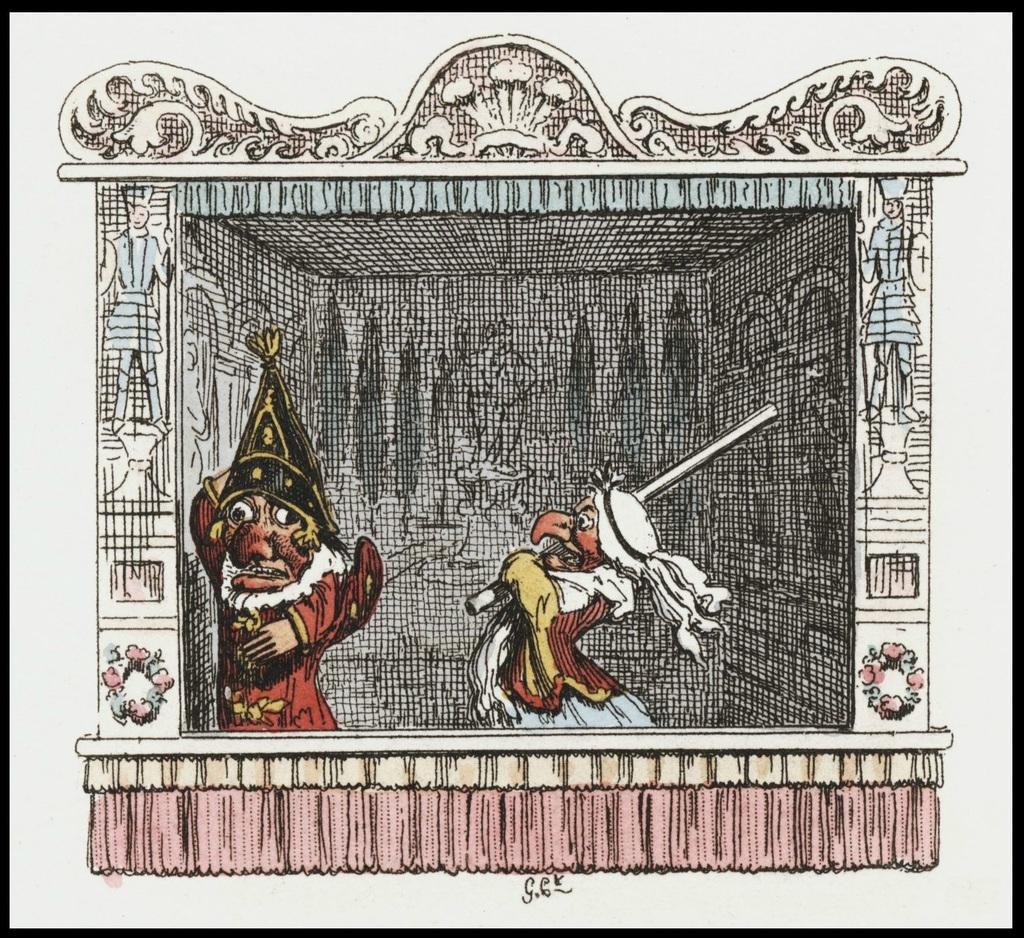Please provide a concise description of this image. In this image we can see the depictions of people, flowers. We can see a person holding a stick. Background is completely messy and it's in black color. 